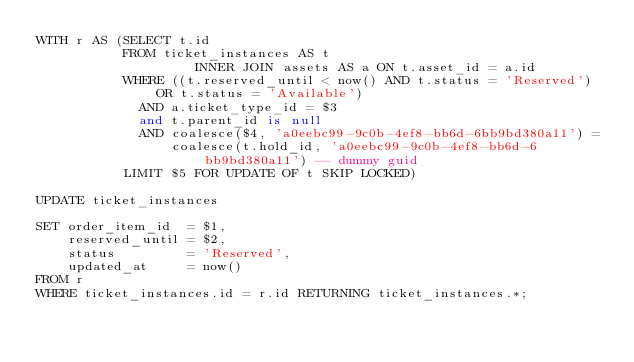Convert code to text. <code><loc_0><loc_0><loc_500><loc_500><_SQL_>WITH r AS (SELECT t.id
           FROM ticket_instances AS t
                    INNER JOIN assets AS a ON t.asset_id = a.id
           WHERE ((t.reserved_until < now() AND t.status = 'Reserved') OR t.status = 'Available')
             AND a.ticket_type_id = $3
             and t.parent_id is null
             AND coalesce($4, 'a0eebc99-9c0b-4ef8-bb6d-6bb9bd380a11') =
                 coalesce(t.hold_id, 'a0eebc99-9c0b-4ef8-bb6d-6bb9bd380a11') -- dummy guid
           LIMIT $5 FOR UPDATE OF t SKIP LOCKED)

UPDATE ticket_instances

SET order_item_id  = $1,
    reserved_until = $2,
    status         = 'Reserved',
    updated_at     = now()
FROM r
WHERE ticket_instances.id = r.id RETURNING ticket_instances.*;

</code> 